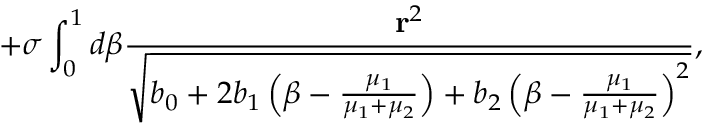<formula> <loc_0><loc_0><loc_500><loc_500>+ \sigma \int _ { 0 } ^ { 1 } d \beta \frac { { r } ^ { 2 } } { \sqrt { b _ { 0 } + 2 b _ { 1 } \left ( \beta - \frac { \mu _ { 1 } } { \mu _ { 1 } + \mu _ { 2 } } \right ) + b _ { 2 } \left ( \beta - \frac { \mu _ { 1 } } { \mu _ { 1 } + \mu _ { 2 } } \right ) ^ { 2 } } } ,</formula> 